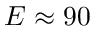<formula> <loc_0><loc_0><loc_500><loc_500>E \approx 9 0</formula> 